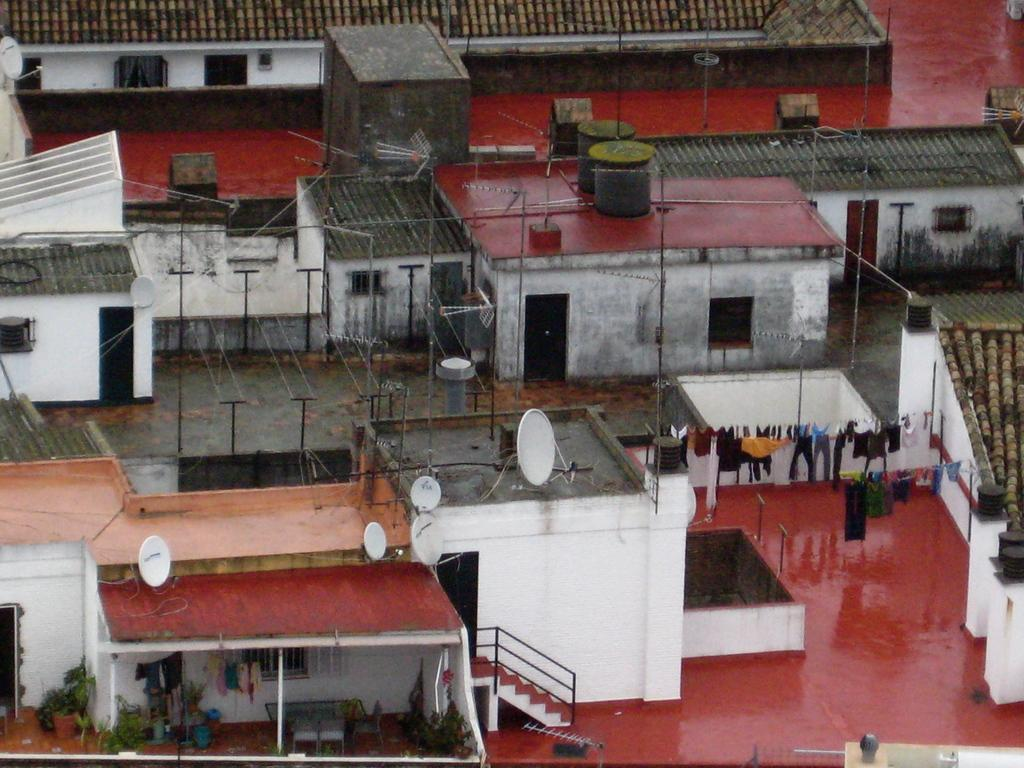What type of structures are present in the image? There are buildings with windows in the image. What objects can be seen supporting something or providing a pathway? Poles are present in the image. What items are hanging or displayed in the image? Clothes are visible in the image. What architectural feature is present in the image for ascending or descending? There are steps in the image. What type of plants can be seen in the image? House plants are present in the image. What type of furniture is visible in the image? There is a table and chairs in the image. What type of gold ornament is hanging from the sign in the image? There is no sign or gold ornament present in the image. Can you tell me how many skateboards are visible in the image? There are no skateboards present in the image. 